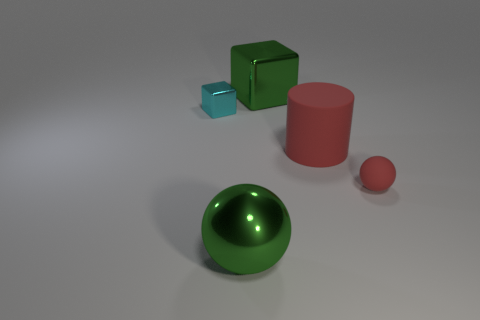Add 5 small blue metallic objects. How many objects exist? 10 Subtract all green blocks. How many blocks are left? 1 Subtract 1 cylinders. How many cylinders are left? 0 Subtract all large green rubber spheres. Subtract all big green shiny spheres. How many objects are left? 4 Add 5 red spheres. How many red spheres are left? 6 Add 4 large gray metallic objects. How many large gray metallic objects exist? 4 Subtract 0 cyan spheres. How many objects are left? 5 Subtract all cylinders. How many objects are left? 4 Subtract all yellow blocks. Subtract all gray cylinders. How many blocks are left? 2 